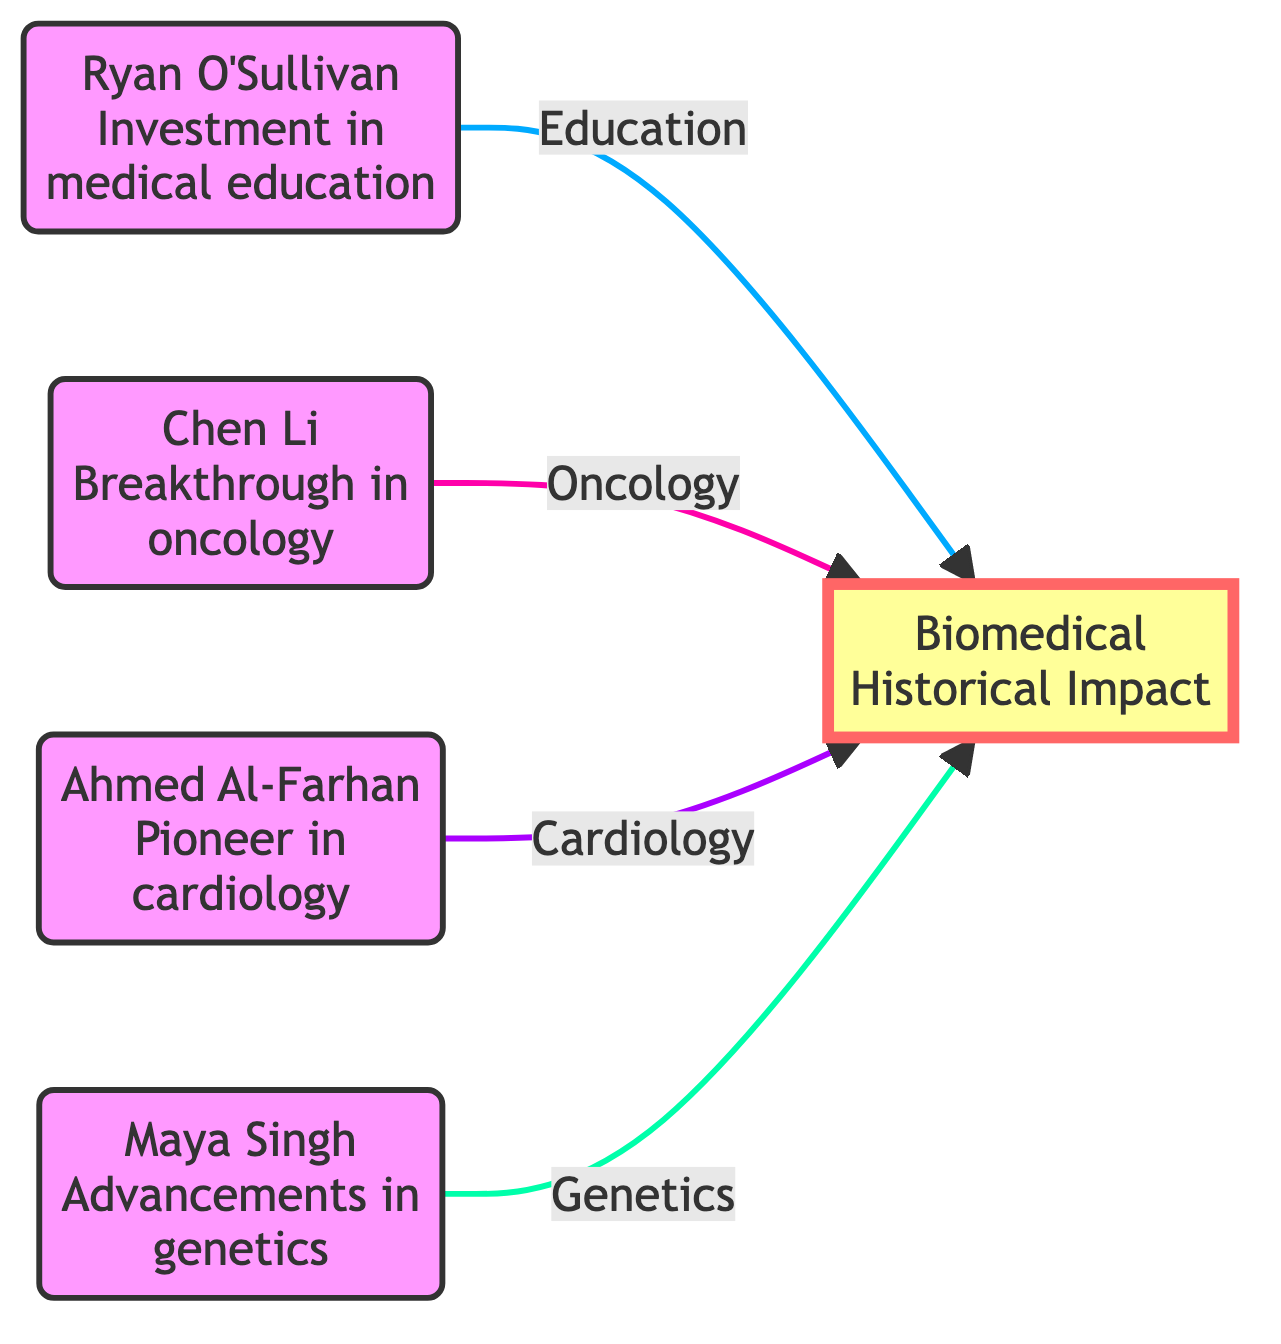What is the name of the medical personality focused on education? The diagram indicates that Ryan O'Sullivan is associated with investment in medical education, making him the medical personality focused on this area.
Answer: Ryan O'Sullivan Which medical field does Maya Singh contribute to? According to the diagram, Maya Singh is linked to advancements in genetics, indicating that her contributions are in the field of genetics.
Answer: Genetics How many medical personalities are depicted in the diagram? By counting the nodes representing medical personalities, we find there are four personalities: Ryan O'Sullivan, Chen Li, Ahmed Al-Farhan, and Maya Singh, which totals to four.
Answer: 4 What contribution is associated with Ahmed Al-Farhan? The diagram shows that Ahmed Al-Farhan is identified as a pioneer in cardiology, directly indicating his contribution.
Answer: Cardiology What is the overall impact area represented at the bottom of the diagram? The diagram highlights an overall impact labeled as Biomedical Historical Impact, which encompasses the contributions made by the medical personalities above.
Answer: Biomedical Historical Impact Which medical personality has made a breakthrough in oncology? The diagram explicitly connects Chen Li with a breakthrough in oncology, making him the relevant medical personality for this field.
Answer: Chen Li What type of diagram is represented here? This diagram is a flowchart, organized to showcase the relationships and contributions of various medical personalities thus depicting their interconnections and overall impact visually.
Answer: Flowchart 